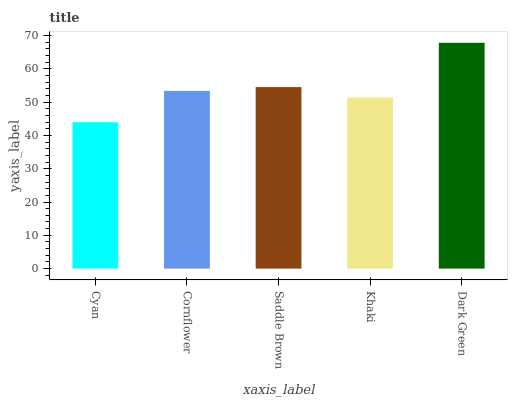Is Cyan the minimum?
Answer yes or no. Yes. Is Dark Green the maximum?
Answer yes or no. Yes. Is Cornflower the minimum?
Answer yes or no. No. Is Cornflower the maximum?
Answer yes or no. No. Is Cornflower greater than Cyan?
Answer yes or no. Yes. Is Cyan less than Cornflower?
Answer yes or no. Yes. Is Cyan greater than Cornflower?
Answer yes or no. No. Is Cornflower less than Cyan?
Answer yes or no. No. Is Cornflower the high median?
Answer yes or no. Yes. Is Cornflower the low median?
Answer yes or no. Yes. Is Cyan the high median?
Answer yes or no. No. Is Cyan the low median?
Answer yes or no. No. 